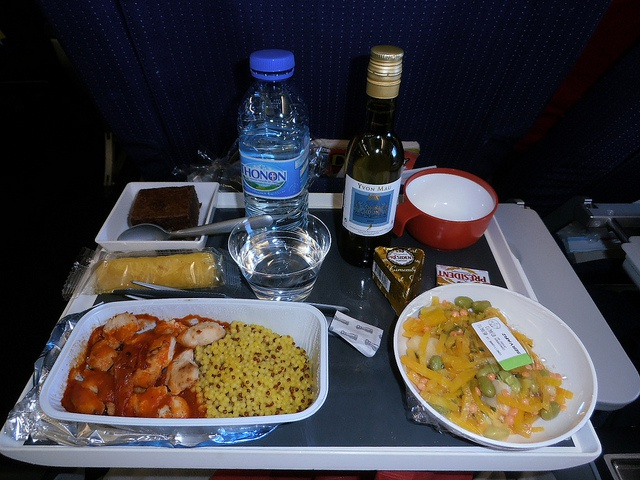Describe the objects in this image and their specific colors. I can see bowl in black, olive, lavender, and darkgray tones, bottle in black, darkgray, and gray tones, bottle in black, navy, and blue tones, cup in black, gray, blue, and navy tones, and bowl in black, darkgray, and gray tones in this image. 